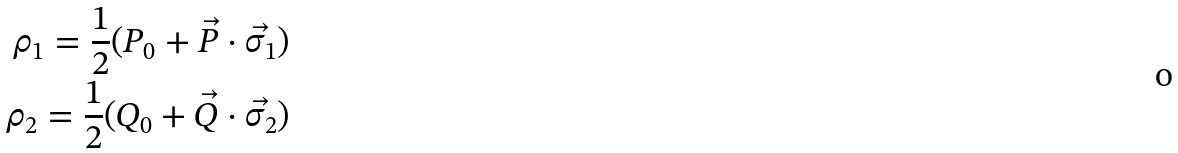<formula> <loc_0><loc_0><loc_500><loc_500>\rho _ { 1 } = \frac { 1 } { 2 } ( P _ { 0 } + \vec { P } \cdot \vec { \sigma _ { 1 } } ) \\ \rho _ { 2 } = \frac { 1 } { 2 } ( Q _ { 0 } + \vec { Q } \cdot \vec { \sigma _ { 2 } } )</formula> 